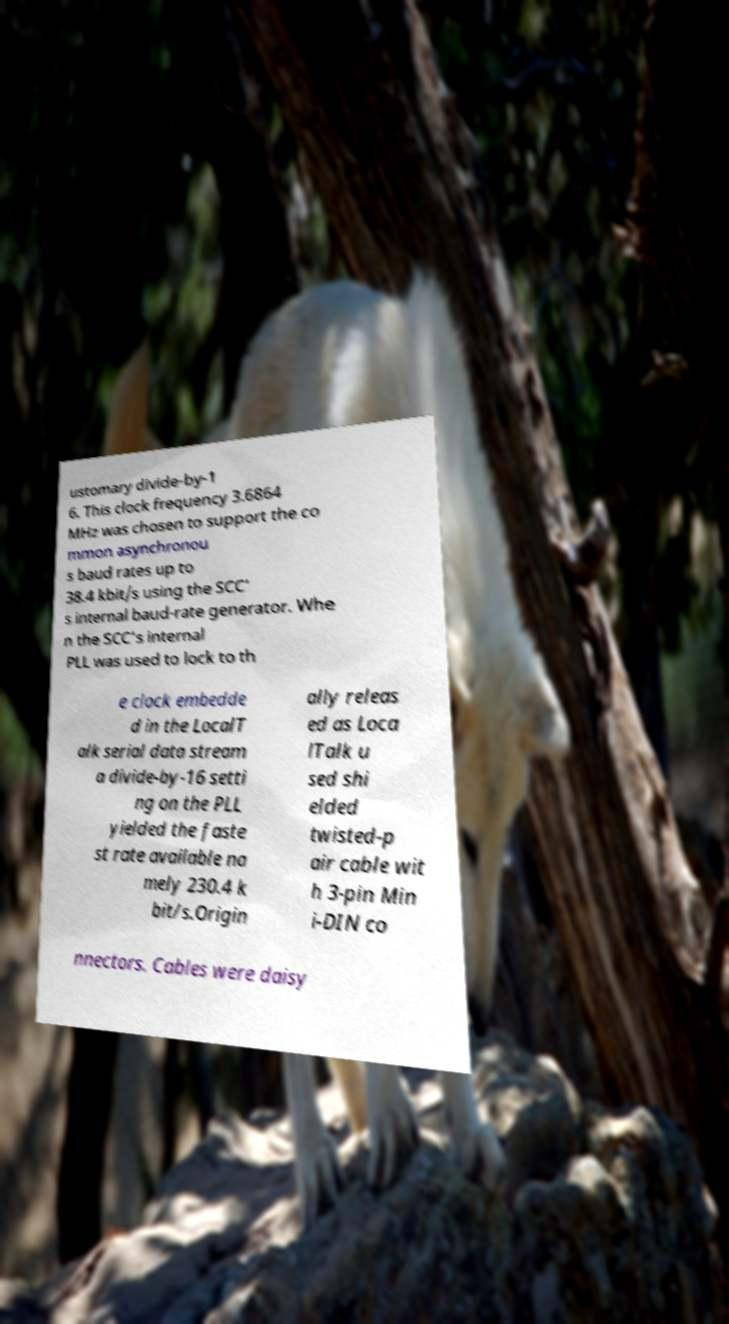What messages or text are displayed in this image? I need them in a readable, typed format. ustomary divide-by-1 6. This clock frequency 3.6864 MHz was chosen to support the co mmon asynchronou s baud rates up to 38.4 kbit/s using the SCC' s internal baud-rate generator. Whe n the SCC's internal PLL was used to lock to th e clock embedde d in the LocalT alk serial data stream a divide-by-16 setti ng on the PLL yielded the faste st rate available na mely 230.4 k bit/s.Origin ally releas ed as Loca lTalk u sed shi elded twisted-p air cable wit h 3-pin Min i-DIN co nnectors. Cables were daisy 